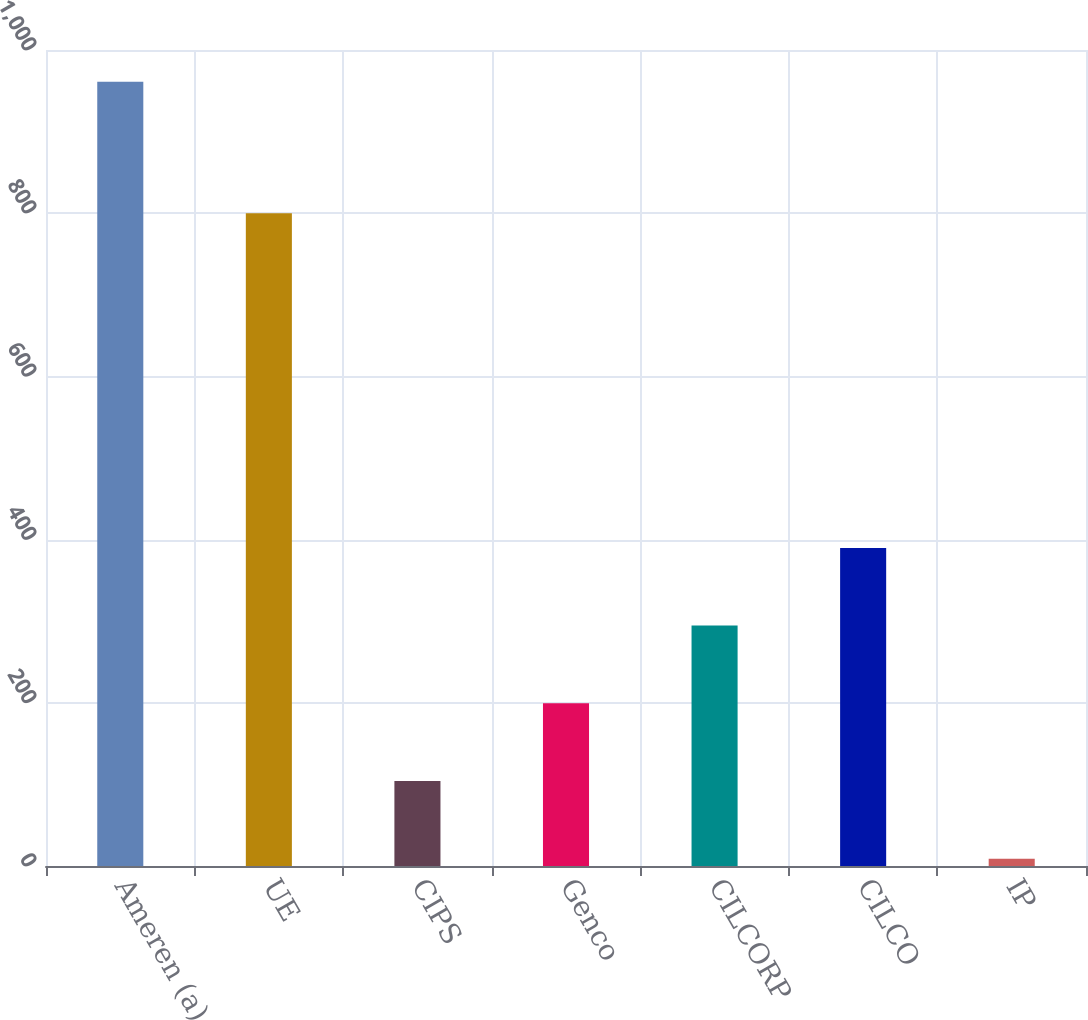Convert chart to OTSL. <chart><loc_0><loc_0><loc_500><loc_500><bar_chart><fcel>Ameren (a)<fcel>UE<fcel>CIPS<fcel>Genco<fcel>CILCORP<fcel>CILCO<fcel>IP<nl><fcel>961<fcel>800<fcel>104.2<fcel>199.4<fcel>294.6<fcel>389.8<fcel>9<nl></chart> 